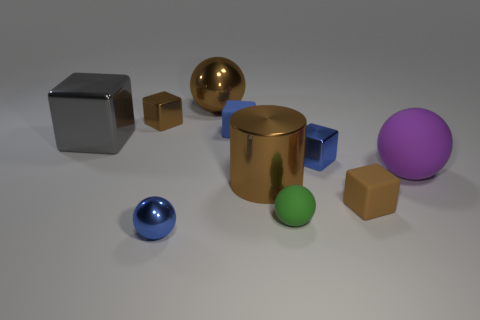What number of matte objects are either small blue objects or big cylinders?
Your answer should be compact. 1. What is the shape of the tiny brown thing that is made of the same material as the gray block?
Provide a succinct answer. Cube. What number of cubes are both in front of the large cylinder and left of the brown shiny cube?
Ensure brevity in your answer.  0. Is there any other thing that has the same shape as the gray thing?
Ensure brevity in your answer.  Yes. There is a brown metallic thing that is right of the large brown metallic sphere; what is its size?
Offer a very short reply. Large. How many other things are there of the same color as the metal cylinder?
Your answer should be compact. 3. There is a big thing to the right of the small brown block in front of the large purple ball; what is it made of?
Offer a terse response. Rubber. There is a rubber cube that is in front of the purple matte sphere; is it the same color as the metal cylinder?
Your answer should be very brief. Yes. How many small things have the same shape as the large gray thing?
Keep it short and to the point. 4. There is a blue thing that is the same material as the purple ball; what size is it?
Provide a succinct answer. Small. 